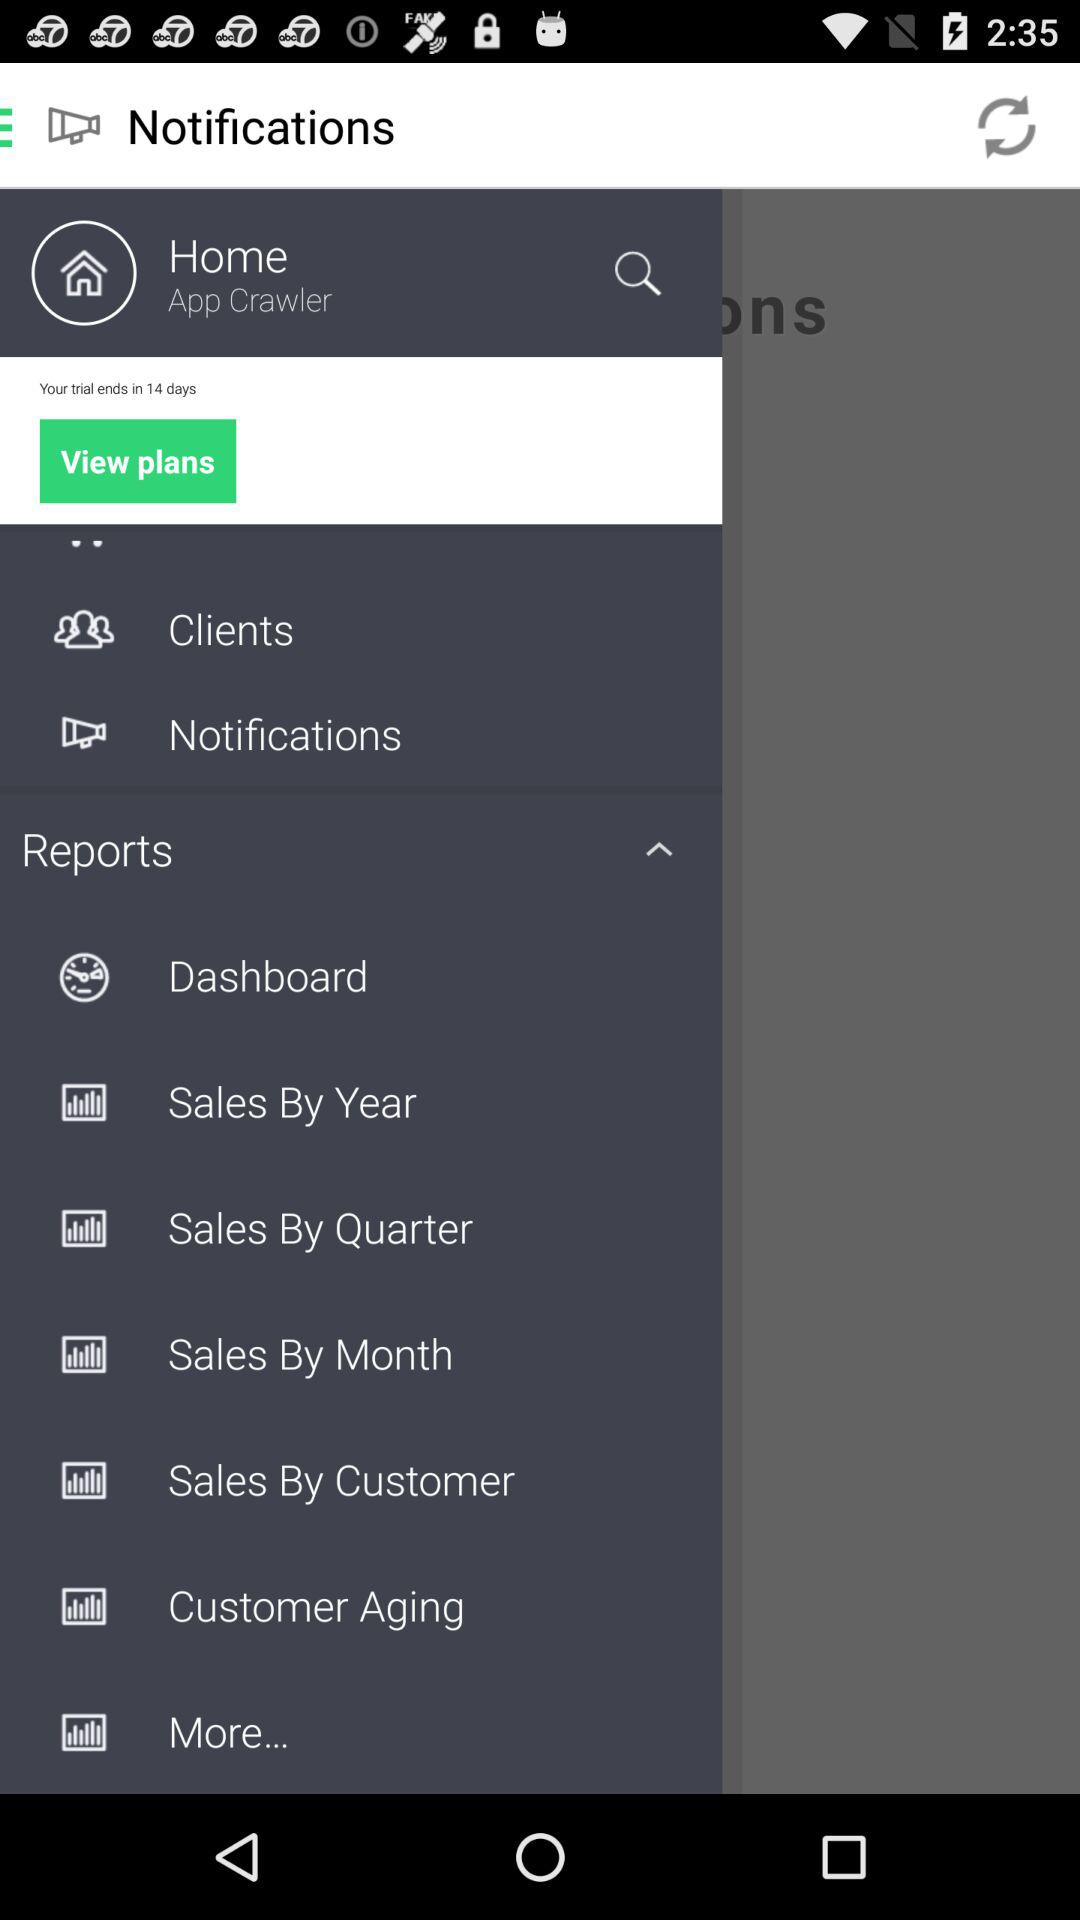How many notifications are there in "Clients"?
When the provided information is insufficient, respond with <no answer>. <no answer> 